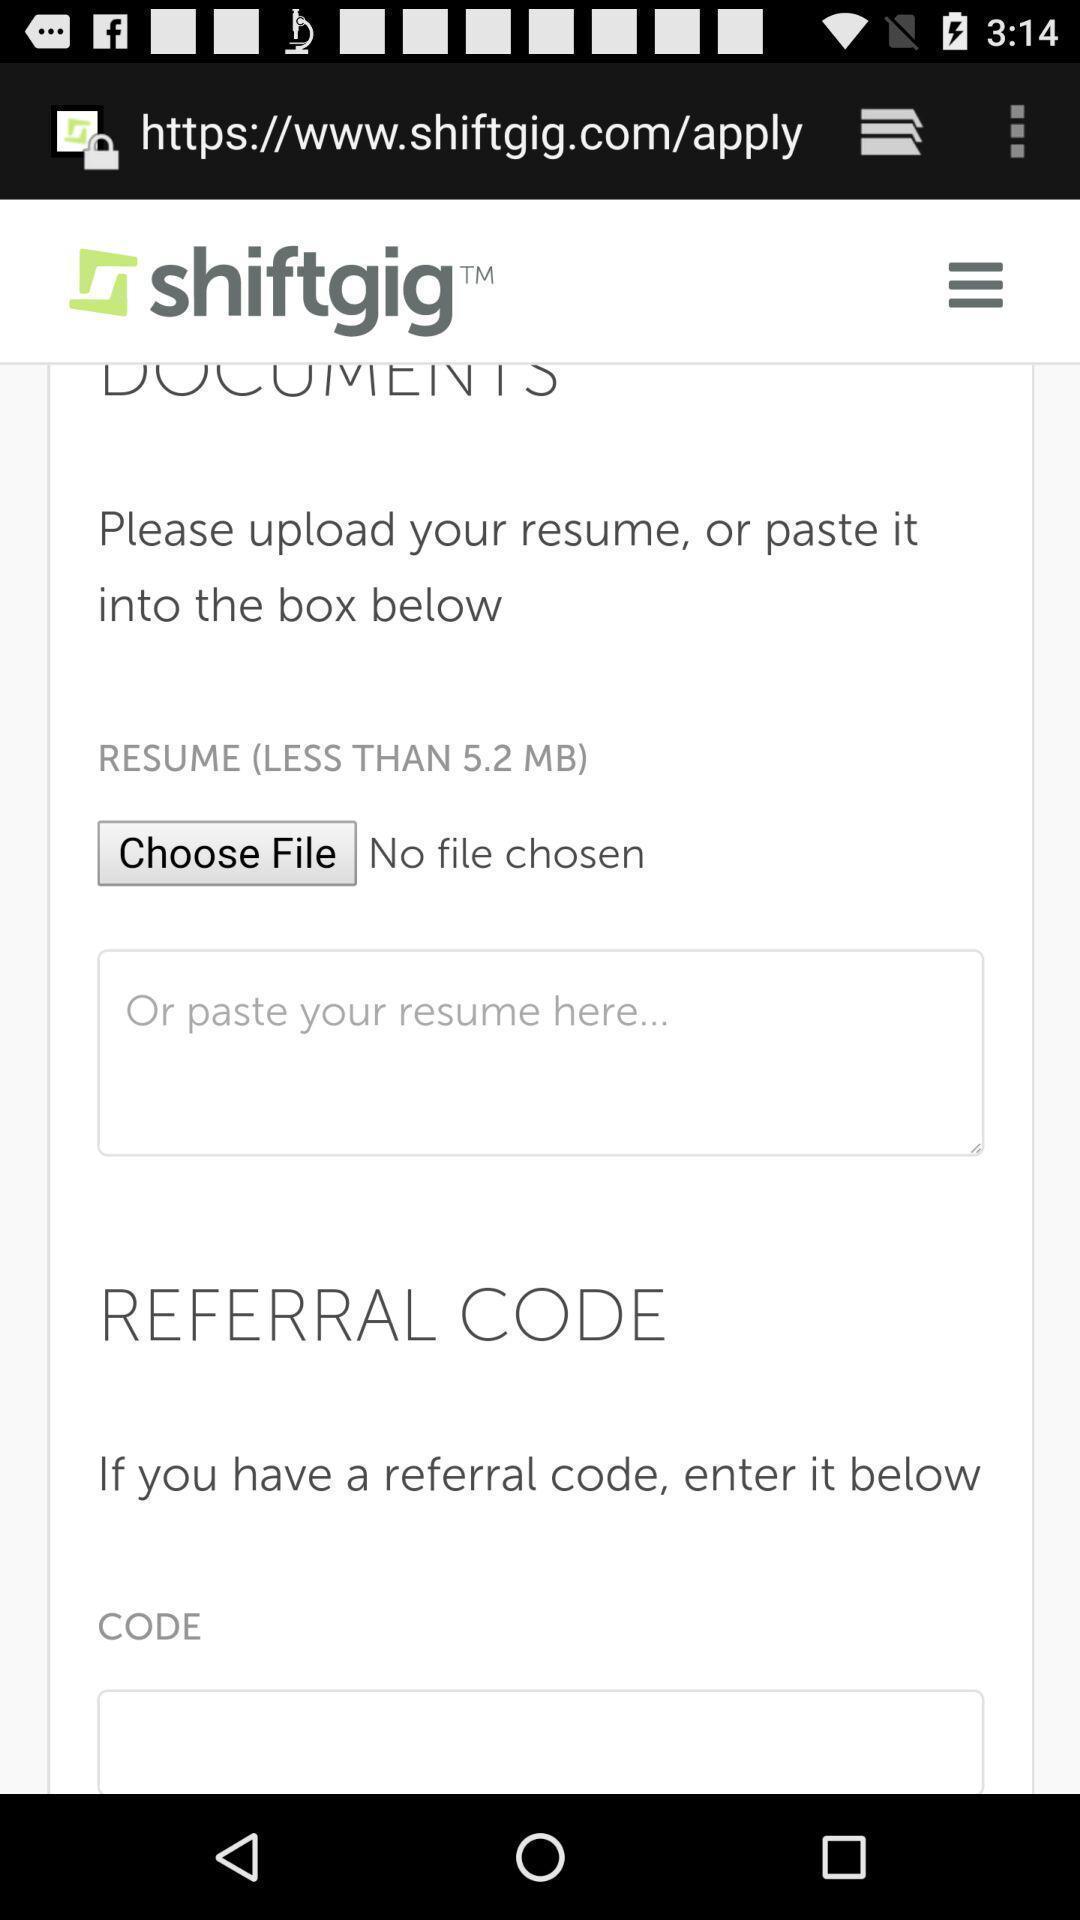Describe this image in words. Screen displaying the page asking to enter the data. 